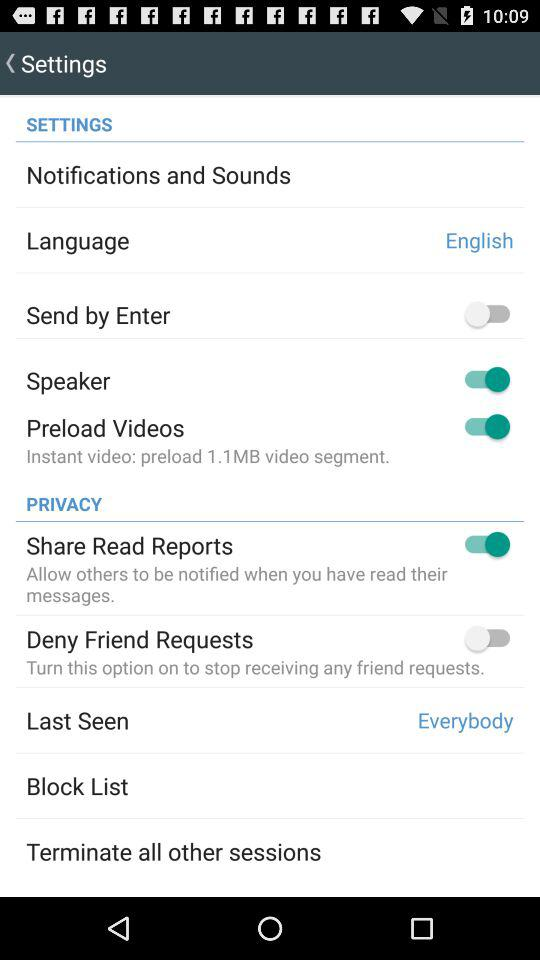How many items are under the Privacy section?
Answer the question using a single word or phrase. 5 